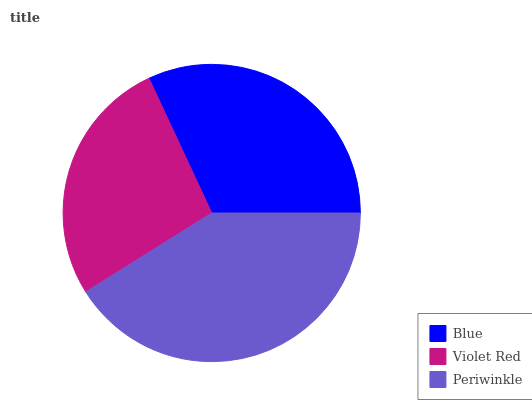Is Violet Red the minimum?
Answer yes or no. Yes. Is Periwinkle the maximum?
Answer yes or no. Yes. Is Periwinkle the minimum?
Answer yes or no. No. Is Violet Red the maximum?
Answer yes or no. No. Is Periwinkle greater than Violet Red?
Answer yes or no. Yes. Is Violet Red less than Periwinkle?
Answer yes or no. Yes. Is Violet Red greater than Periwinkle?
Answer yes or no. No. Is Periwinkle less than Violet Red?
Answer yes or no. No. Is Blue the high median?
Answer yes or no. Yes. Is Blue the low median?
Answer yes or no. Yes. Is Periwinkle the high median?
Answer yes or no. No. Is Violet Red the low median?
Answer yes or no. No. 